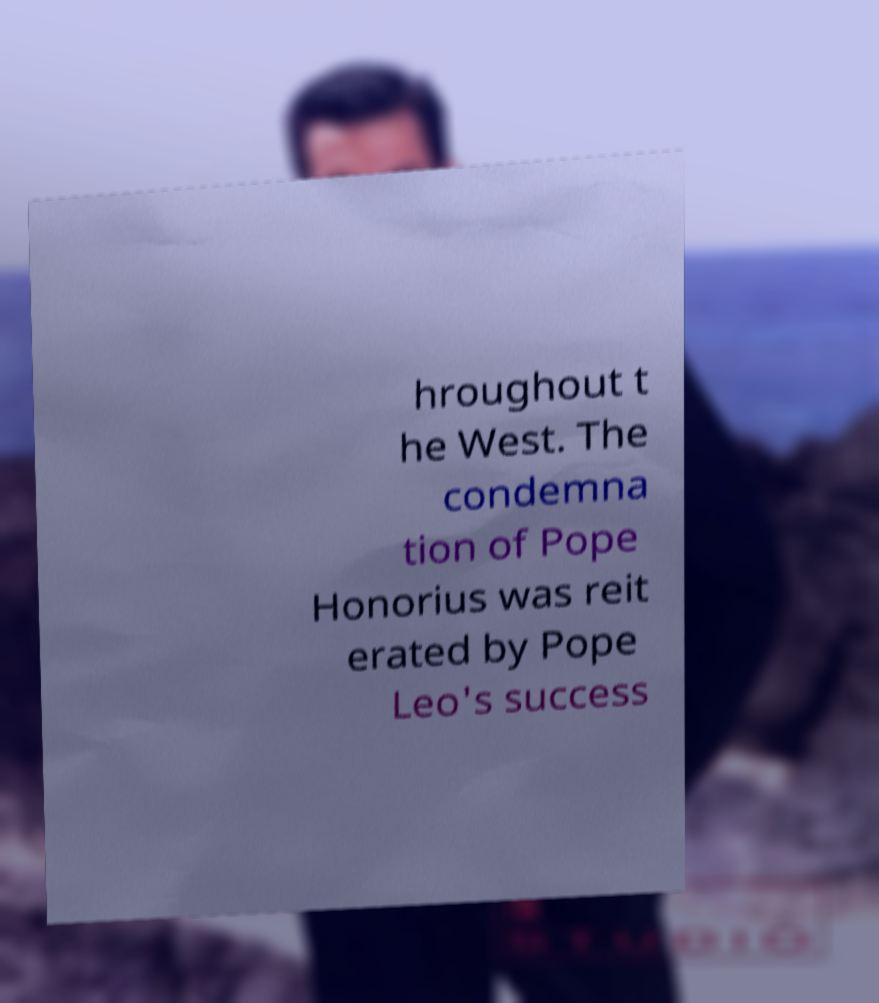Could you assist in decoding the text presented in this image and type it out clearly? hroughout t he West. The condemna tion of Pope Honorius was reit erated by Pope Leo's success 